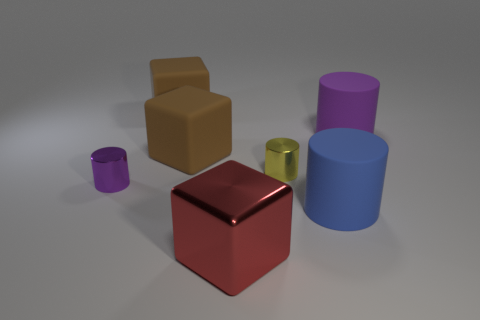The tiny purple object has what shape?
Offer a very short reply. Cylinder. There is a large brown block that is behind the large purple thing; what is it made of?
Give a very brief answer. Rubber. There is a matte cylinder that is behind the small thing on the left side of the small cylinder that is behind the purple shiny thing; what is its color?
Your answer should be compact. Purple. What color is the shiny block that is the same size as the purple rubber cylinder?
Offer a very short reply. Red. What number of metallic things are large objects or large yellow cylinders?
Make the answer very short. 1. What color is the big cylinder that is made of the same material as the blue thing?
Your answer should be compact. Purple. What is the material of the purple object that is left of the matte thing that is in front of the purple shiny thing?
Your answer should be compact. Metal. How many objects are either large blocks behind the purple metallic object or things in front of the small yellow metallic cylinder?
Ensure brevity in your answer.  5. How big is the cylinder that is on the left side of the cube in front of the tiny metal object that is to the left of the tiny yellow metallic thing?
Provide a short and direct response. Small. Are there an equal number of large rubber things on the right side of the red block and matte cubes?
Offer a very short reply. Yes. 